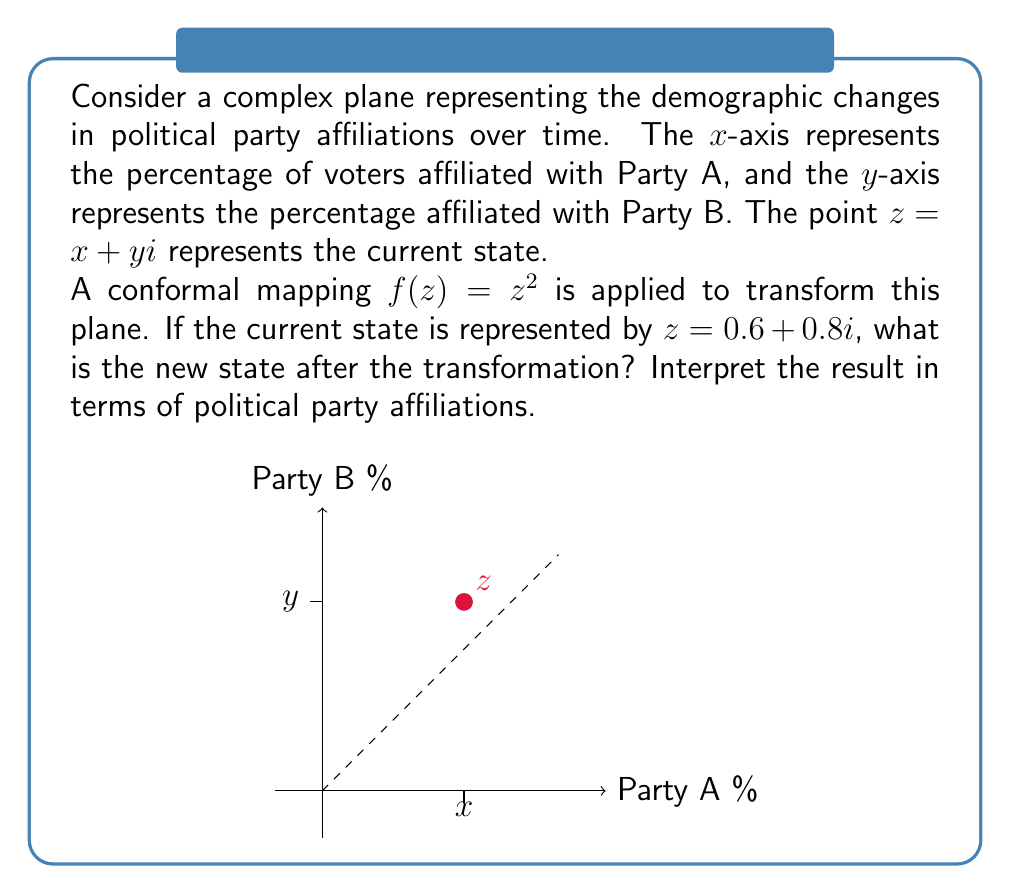What is the answer to this math problem? Let's approach this step-by-step:

1) We start with z = 0.6 + 0.8i, which represents the current state where 60% of voters are affiliated with Party A and 80% with Party B.

2) The conformal mapping is given by f(z) = z^2. We need to apply this to our z:

   f(z) = (0.6 + 0.8i)^2

3) To square a complex number, we can use the formula (a + bi)^2 = (a^2 - b^2) + 2abi:

   f(z) = (0.6^2 - 0.8^2) + 2(0.6)(0.8)i

4) Let's calculate:
   0.6^2 = 0.36
   0.8^2 = 0.64
   2(0.6)(0.8) = 0.96

5) Substituting these values:

   f(z) = (0.36 - 0.64) + 0.96i
        = -0.28 + 0.96i

6) Interpreting the result:
   - The real part (-0.28) represents the new affiliation percentage for Party A.
   - The imaginary part (0.96) represents the new affiliation percentage for Party B.

7) However, negative percentages don't make sense in this context. We can interpret this as:
   - Party A has lost 28% of its original affiliation.
   - Party B has gained, with affiliation now at 96%.

This transformation has exaggerated the difference between the parties, showing a trend of Party B gaining significant ground while Party A loses support.
Answer: f(z) = -0.28 + 0.96i, representing a 28% decrease for Party A and 96% affiliation for Party B. 